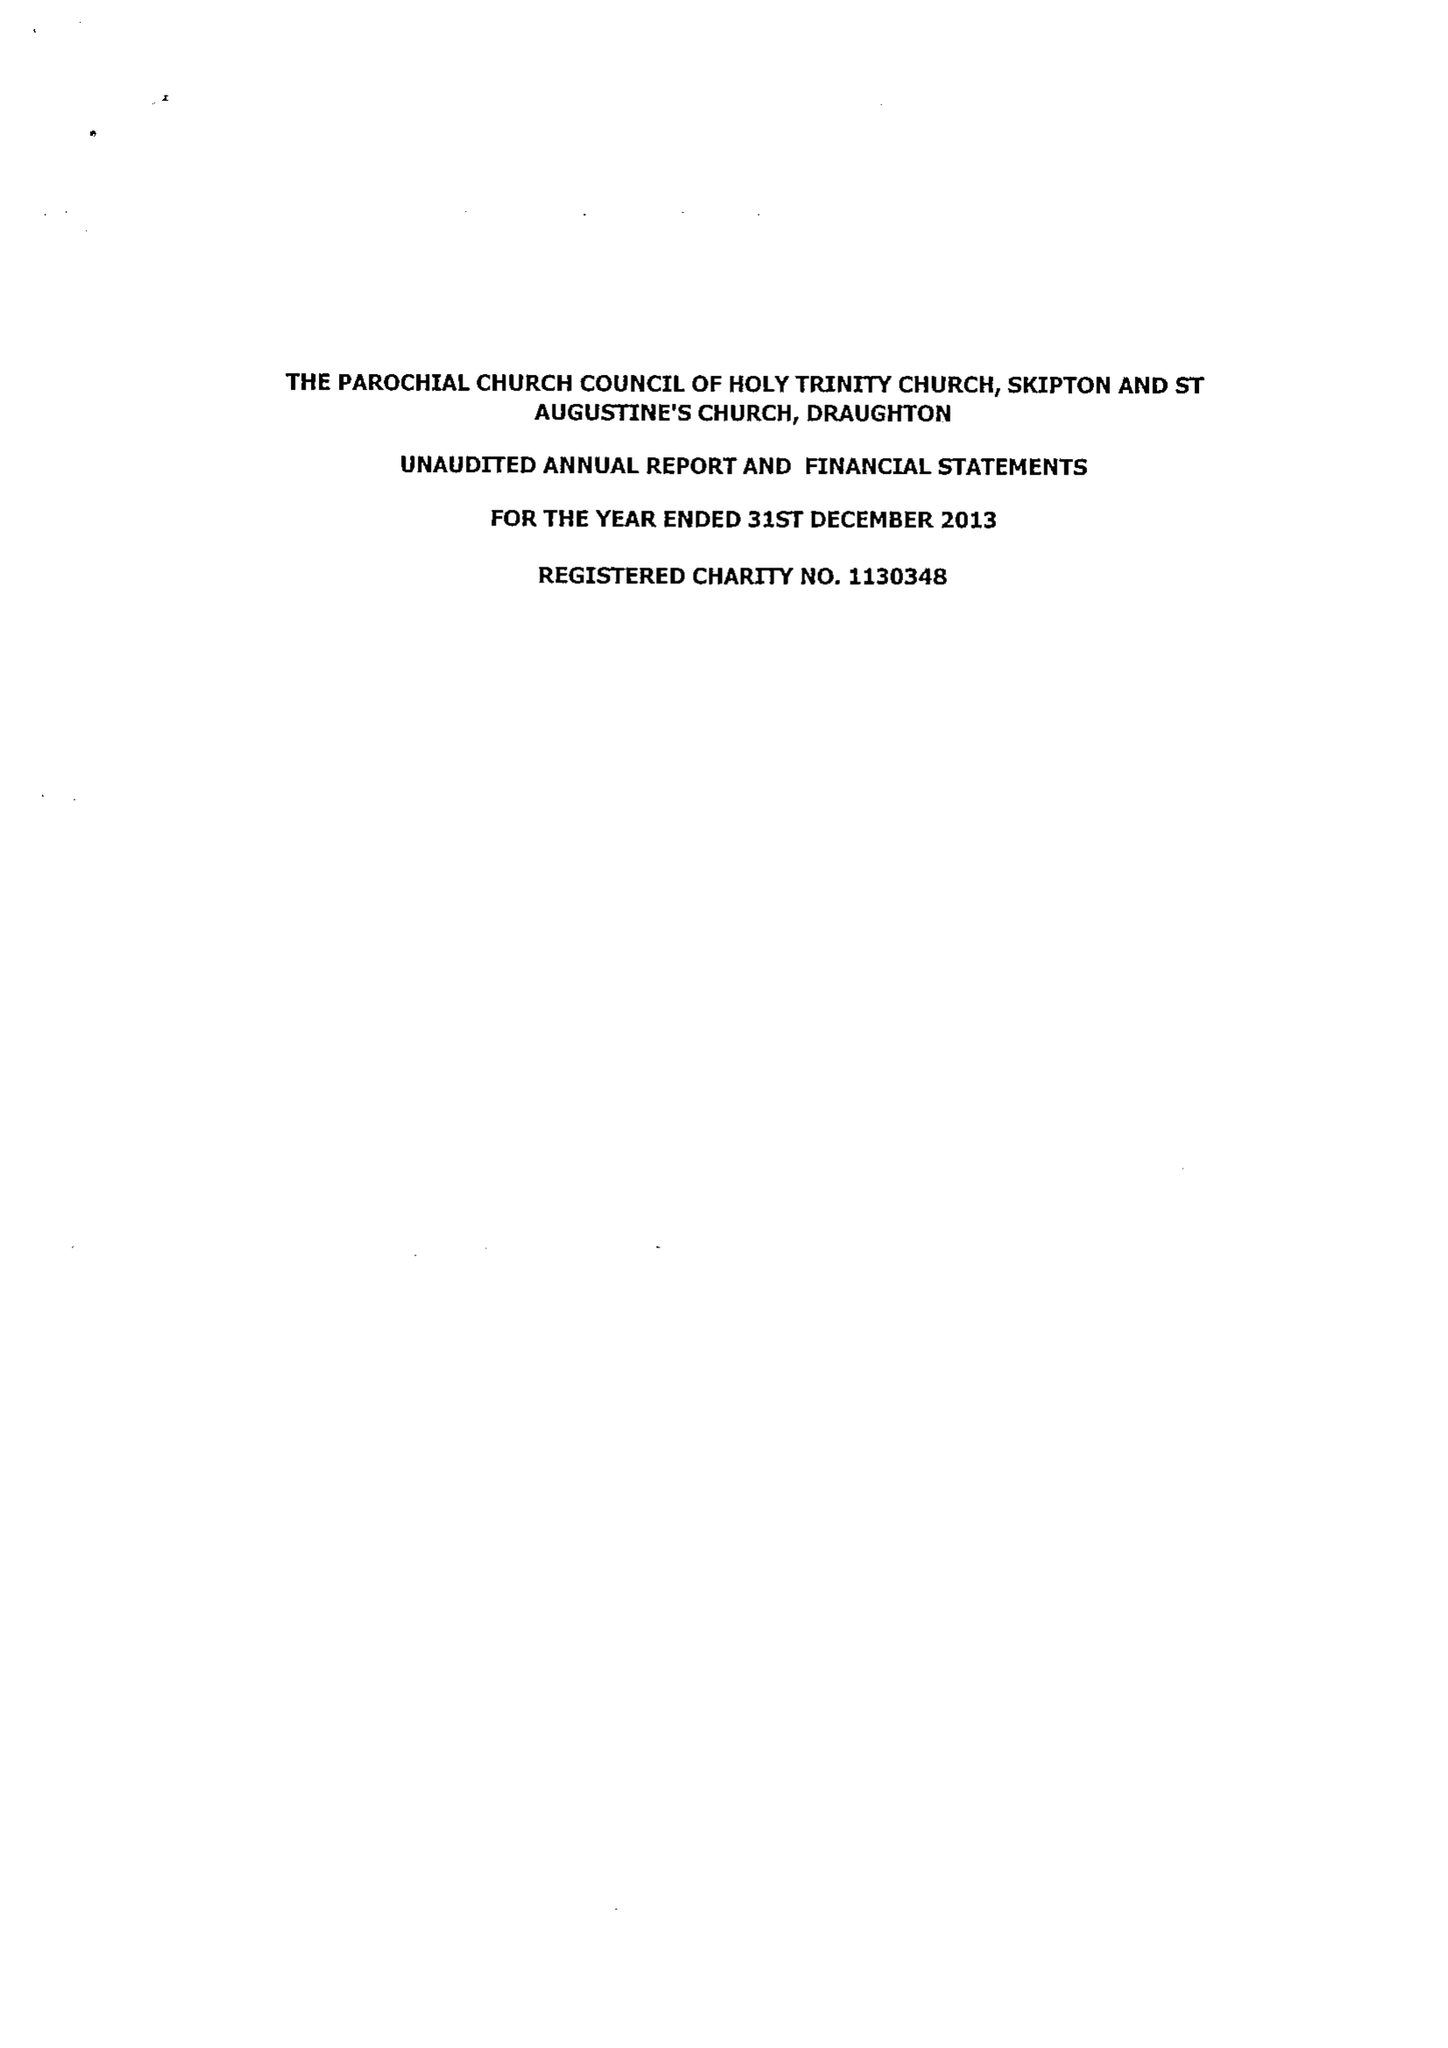What is the value for the charity_number?
Answer the question using a single word or phrase. 1130348 